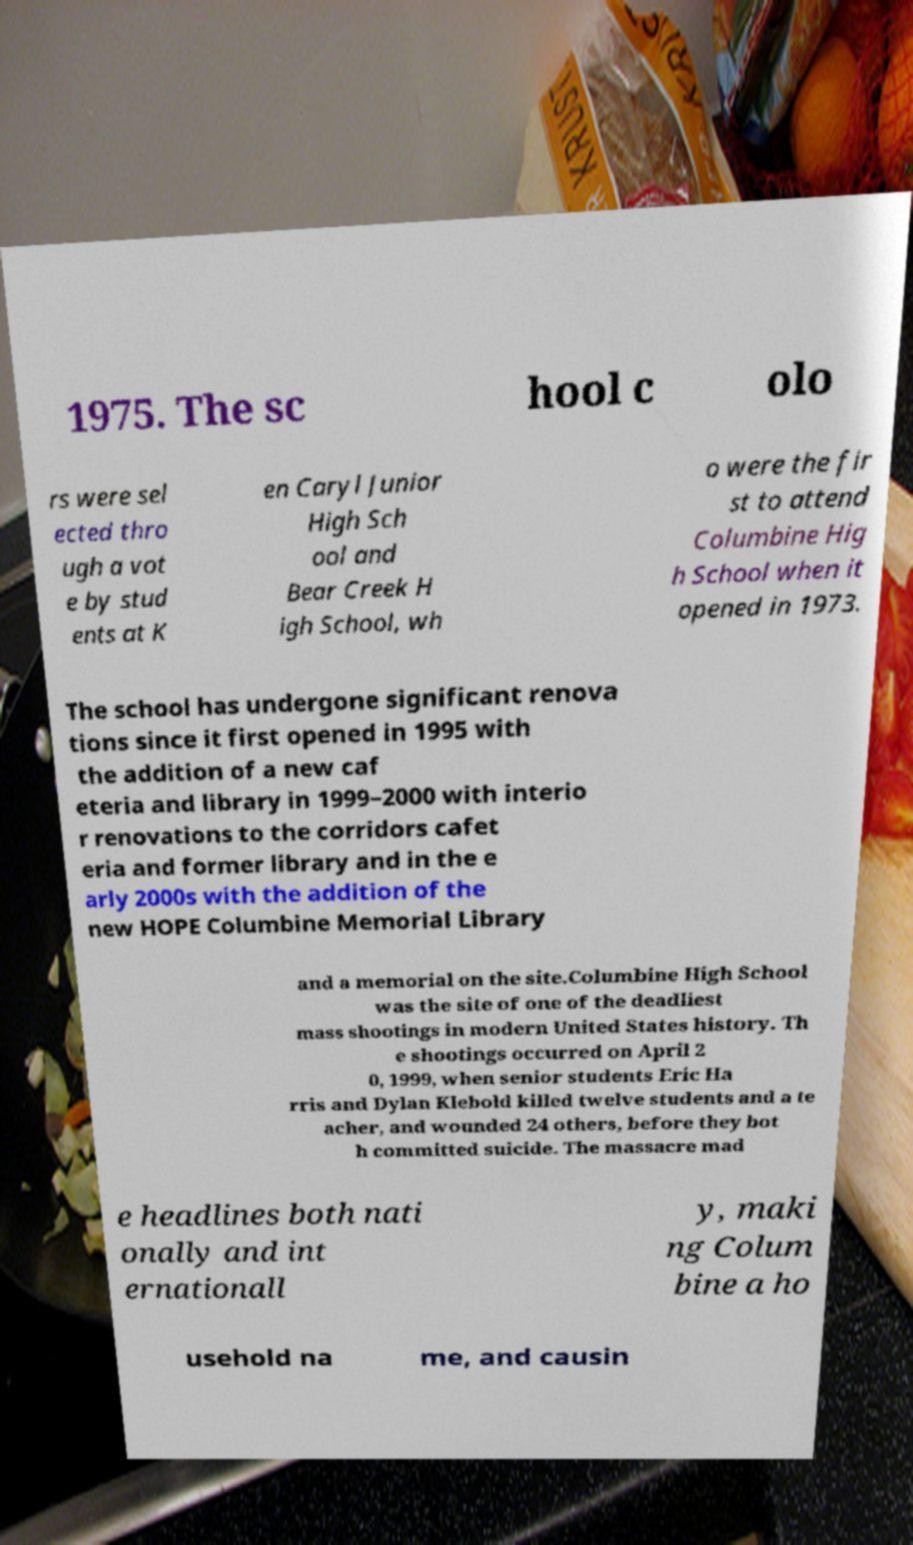I need the written content from this picture converted into text. Can you do that? 1975. The sc hool c olo rs were sel ected thro ugh a vot e by stud ents at K en Caryl Junior High Sch ool and Bear Creek H igh School, wh o were the fir st to attend Columbine Hig h School when it opened in 1973. The school has undergone significant renova tions since it first opened in 1995 with the addition of a new caf eteria and library in 1999–2000 with interio r renovations to the corridors cafet eria and former library and in the e arly 2000s with the addition of the new HOPE Columbine Memorial Library and a memorial on the site.Columbine High School was the site of one of the deadliest mass shootings in modern United States history. Th e shootings occurred on April 2 0, 1999, when senior students Eric Ha rris and Dylan Klebold killed twelve students and a te acher, and wounded 24 others, before they bot h committed suicide. The massacre mad e headlines both nati onally and int ernationall y, maki ng Colum bine a ho usehold na me, and causin 